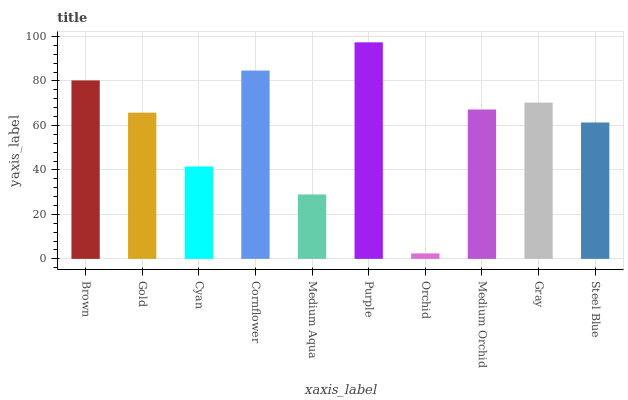Is Orchid the minimum?
Answer yes or no. Yes. Is Purple the maximum?
Answer yes or no. Yes. Is Gold the minimum?
Answer yes or no. No. Is Gold the maximum?
Answer yes or no. No. Is Brown greater than Gold?
Answer yes or no. Yes. Is Gold less than Brown?
Answer yes or no. Yes. Is Gold greater than Brown?
Answer yes or no. No. Is Brown less than Gold?
Answer yes or no. No. Is Medium Orchid the high median?
Answer yes or no. Yes. Is Gold the low median?
Answer yes or no. Yes. Is Gold the high median?
Answer yes or no. No. Is Cyan the low median?
Answer yes or no. No. 